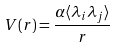Convert formula to latex. <formula><loc_0><loc_0><loc_500><loc_500>V ( r ) = \frac { { \alpha } { \langle \lambda _ { i } \lambda _ { j } \rangle } } { r }</formula> 